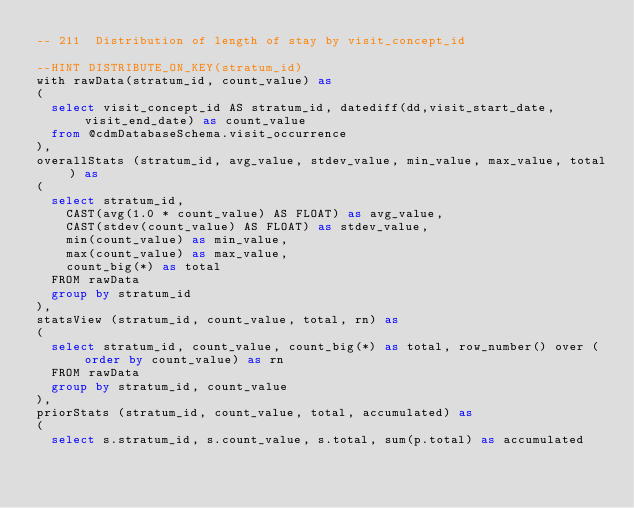<code> <loc_0><loc_0><loc_500><loc_500><_SQL_>-- 211	Distribution of length of stay by visit_concept_id

--HINT DISTRIBUTE_ON_KEY(stratum_id) 
with rawData(stratum_id, count_value) as
(
  select visit_concept_id AS stratum_id, datediff(dd,visit_start_date,visit_end_date) as count_value
  from @cdmDatabaseSchema.visit_occurrence
),
overallStats (stratum_id, avg_value, stdev_value, min_value, max_value, total) as
(
  select stratum_id,
    CAST(avg(1.0 * count_value) AS FLOAT) as avg_value,
    CAST(stdev(count_value) AS FLOAT) as stdev_value,
    min(count_value) as min_value,
    max(count_value) as max_value,
    count_big(*) as total
  FROM rawData
  group by stratum_id
),
statsView (stratum_id, count_value, total, rn) as
(
  select stratum_id, count_value, count_big(*) as total, row_number() over (order by count_value) as rn
  FROM rawData
  group by stratum_id, count_value
),
priorStats (stratum_id, count_value, total, accumulated) as
(
  select s.stratum_id, s.count_value, s.total, sum(p.total) as accumulated</code> 